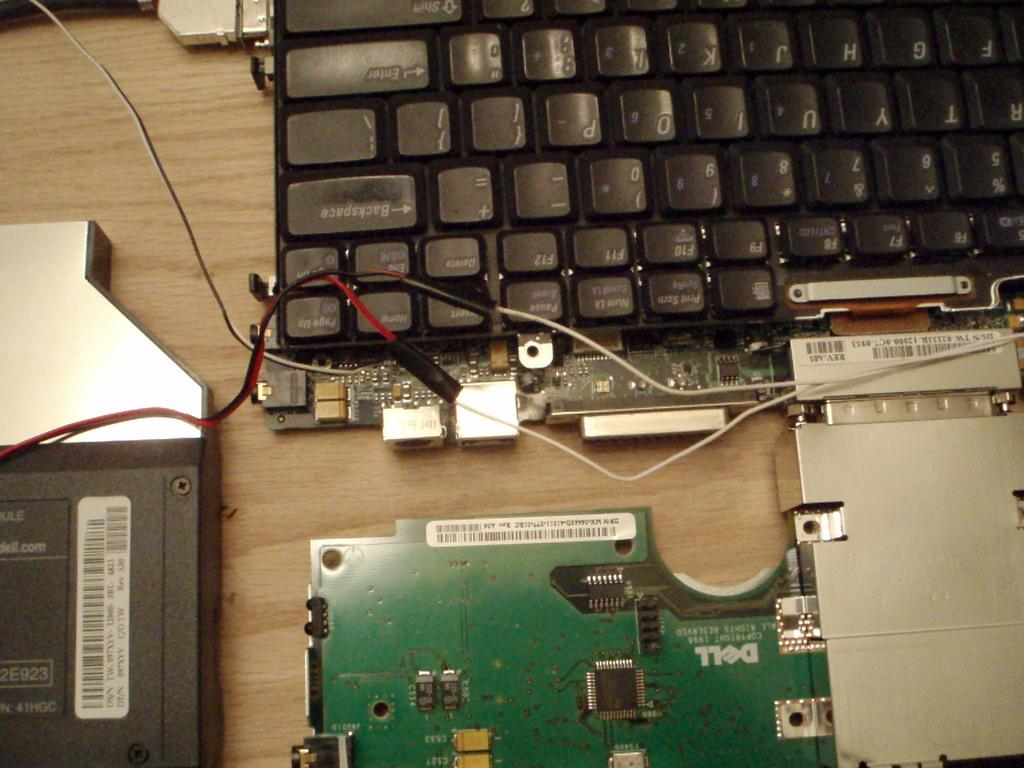<image>
Summarize the visual content of the image. A Dell computer has been taken apart with a green motherboard on display 